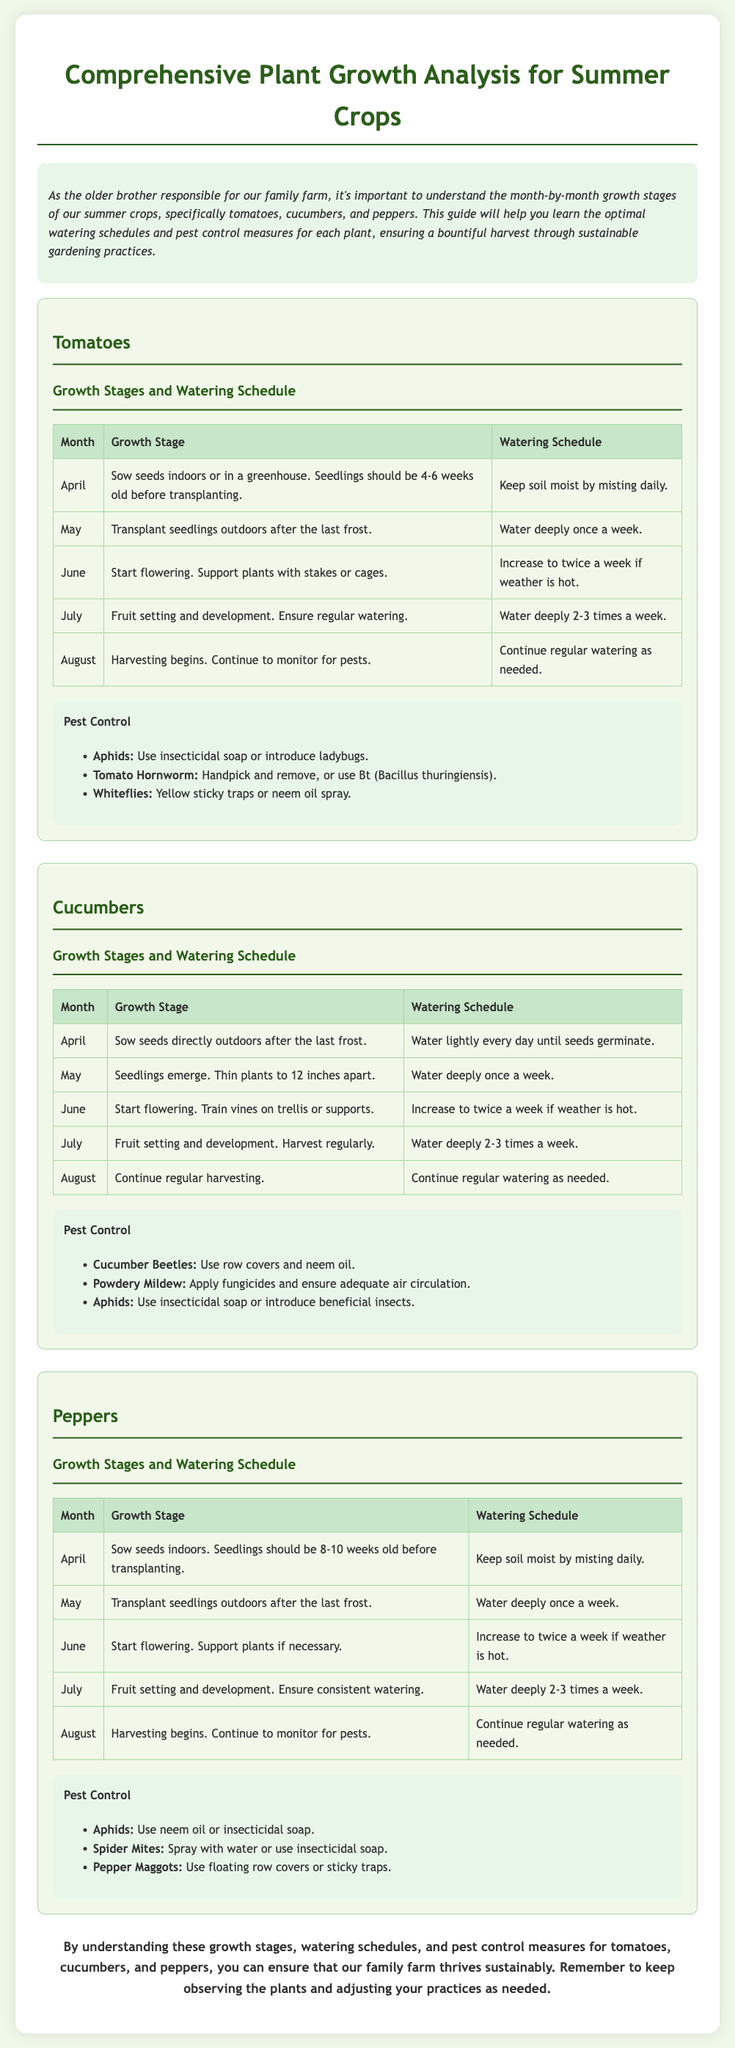What is the first growth stage for tomatoes? The first growth stage for tomatoes, as mentioned in the document, is when seeds are sown indoors or in a greenhouse, and seedlings should be 4-6 weeks old before transplanting.
Answer: Sow seeds indoors How often should cucumbers be watered in May? According to the document, cucumbers should be watered deeply once a week in May.
Answer: Once a week What pest control method is suggested for aphids on tomatoes? The document states that for aphids on tomatoes, one can use insecticidal soap or introduce ladybugs.
Answer: Insecticidal soap How many times a week should pepper plants be watered in July? The document indicates that in July, pepper plants should be watered deeply 2-3 times a week.
Answer: 2-3 times a week During which month does harvesting for cucumbers begin? The document outlines that harvesting for cucumbers begins in July.
Answer: July What is the pest recommended for use against cucumber beetles? The document suggests using row covers and neem oil against cucumber beetles.
Answer: Row covers and neem oil Which month is indicated for transplanting tomato seedlings outdoors? The document specifies May as the month for transplanting tomato seedlings outdoors.
Answer: May What is the optimal watering frequency for tomatoes in August? In August, the document advises continuing regular watering as needed for tomatoes.
Answer: Regular watering as needed 